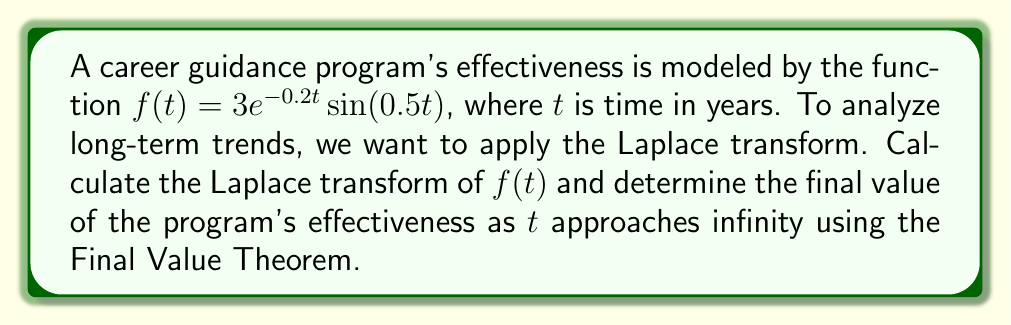Can you solve this math problem? 1) The Laplace transform of $f(t)$ is given by:
   $$F(s) = \mathcal{L}\{f(t)\} = \int_0^\infty f(t)e^{-st}dt$$

2) For $f(t) = 3e^{-0.2t}\sin(0.5t)$, we can use the known Laplace transform:
   $$\mathcal{L}\{e^{at}\sin(bt)\} = \frac{b}{(s-a)^2 + b^2}$$

3) In our case, $a = -0.2$ and $b = 0.5$. Substituting and including the factor of 3:
   $$F(s) = 3 \cdot \frac{0.5}{(s+0.2)^2 + 0.5^2}$$

4) Simplifying:
   $$F(s) = \frac{1.5}{(s+0.2)^2 + 0.25}$$

5) To find the final value as $t$ approaches infinity, we use the Final Value Theorem:
   $$\lim_{t \to \infty} f(t) = \lim_{s \to 0} sF(s)$$

6) Applying this to our $F(s)$:
   $$\lim_{s \to 0} s \cdot \frac{1.5}{(s+0.2)^2 + 0.25}$$

7) As $s$ approaches 0, this limit evaluates to:
   $$\lim_{s \to 0} \frac{1.5s}{0.04 + 0.4s + s^2 + 0.25} = \frac{1.5 \cdot 0}{0.04 + 0.25} = 0$$

Therefore, the final value of the program's effectiveness as $t$ approaches infinity is 0.
Answer: 0 